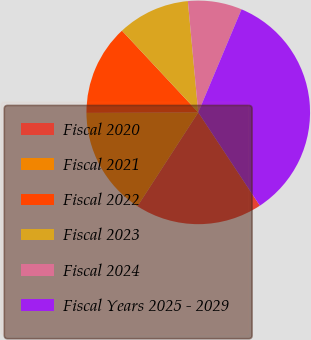Convert chart to OTSL. <chart><loc_0><loc_0><loc_500><loc_500><pie_chart><fcel>Fiscal 2020<fcel>Fiscal 2021<fcel>Fiscal 2022<fcel>Fiscal 2023<fcel>Fiscal 2024<fcel>Fiscal Years 2025 - 2029<nl><fcel>18.44%<fcel>15.78%<fcel>13.12%<fcel>10.47%<fcel>7.81%<fcel>34.38%<nl></chart> 